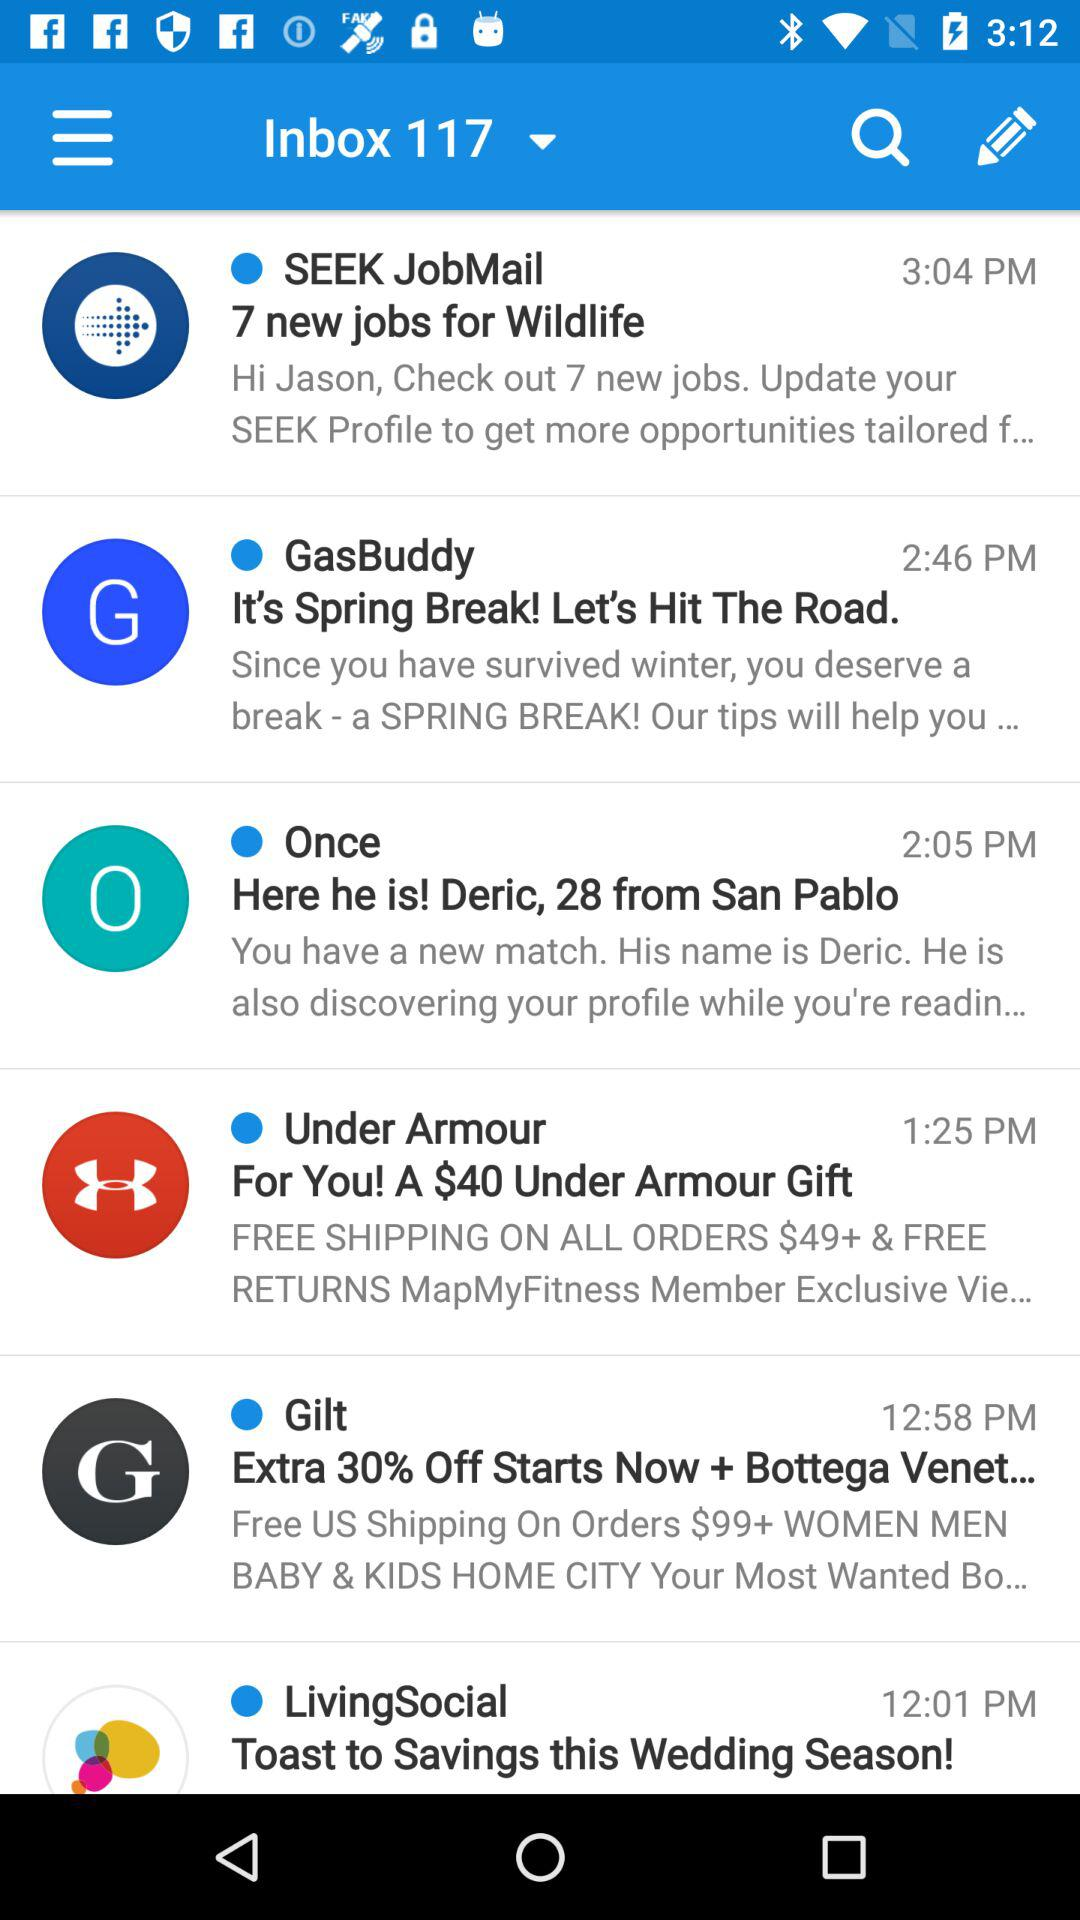When was the email from "Gilt" received? The email was received at 12:58 p.m. 